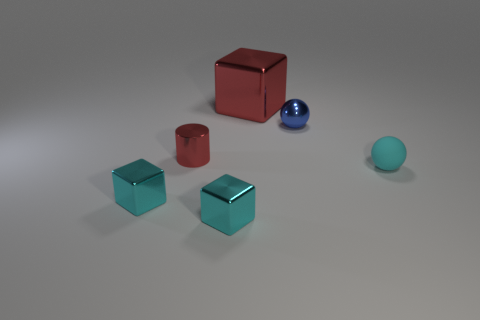There is a object that is the same color as the small cylinder; what is its size?
Offer a very short reply. Large. The red object that is in front of the big red object has what shape?
Provide a succinct answer. Cylinder. There is a small shiny object that is on the right side of the metal block that is behind the tiny cyan matte sphere; how many shiny objects are right of it?
Your answer should be very brief. 0. Does the red metallic cube have the same size as the ball on the left side of the matte ball?
Provide a short and direct response. No. How big is the red metallic thing behind the tiny metal thing that is on the right side of the big cube?
Provide a short and direct response. Large. What number of big cubes have the same material as the red cylinder?
Ensure brevity in your answer.  1. Are there any gray shiny spheres?
Your response must be concise. No. There is a red shiny thing on the right side of the cylinder; how big is it?
Give a very brief answer. Large. What number of tiny metal cylinders are the same color as the large shiny block?
Give a very brief answer. 1. What number of balls are cyan metallic things or tiny red objects?
Give a very brief answer. 0. 